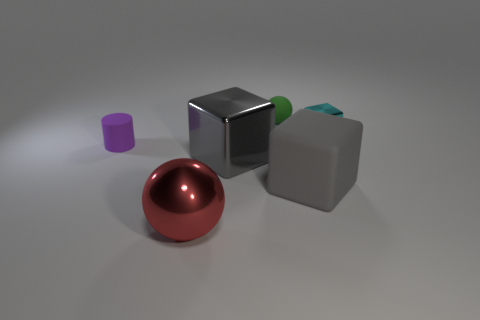Subtract all large blocks. How many blocks are left? 1 Subtract all cyan blocks. How many blocks are left? 2 Subtract 1 balls. How many balls are left? 1 Add 2 big cubes. How many objects exist? 8 Subtract all balls. How many objects are left? 4 Subtract all purple cubes. How many green spheres are left? 1 Subtract all big cyan metal balls. Subtract all matte balls. How many objects are left? 5 Add 4 tiny green objects. How many tiny green objects are left? 5 Add 3 cylinders. How many cylinders exist? 4 Subtract 0 cyan balls. How many objects are left? 6 